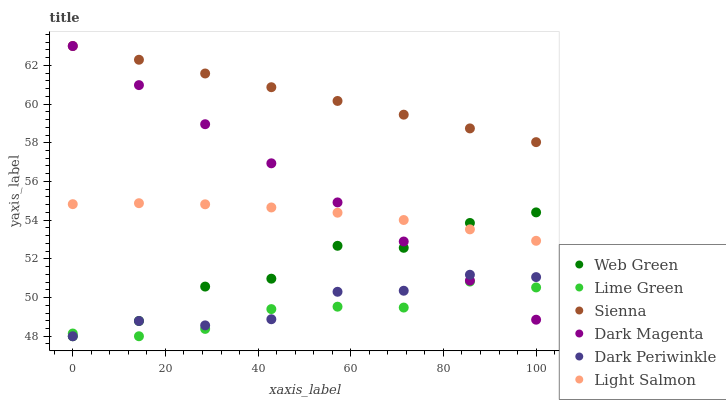Does Lime Green have the minimum area under the curve?
Answer yes or no. Yes. Does Sienna have the maximum area under the curve?
Answer yes or no. Yes. Does Dark Magenta have the minimum area under the curve?
Answer yes or no. No. Does Dark Magenta have the maximum area under the curve?
Answer yes or no. No. Is Sienna the smoothest?
Answer yes or no. Yes. Is Web Green the roughest?
Answer yes or no. Yes. Is Dark Magenta the smoothest?
Answer yes or no. No. Is Dark Magenta the roughest?
Answer yes or no. No. Does Web Green have the lowest value?
Answer yes or no. Yes. Does Dark Magenta have the lowest value?
Answer yes or no. No. Does Sienna have the highest value?
Answer yes or no. Yes. Does Web Green have the highest value?
Answer yes or no. No. Is Lime Green less than Light Salmon?
Answer yes or no. Yes. Is Sienna greater than Dark Periwinkle?
Answer yes or no. Yes. Does Sienna intersect Dark Magenta?
Answer yes or no. Yes. Is Sienna less than Dark Magenta?
Answer yes or no. No. Is Sienna greater than Dark Magenta?
Answer yes or no. No. Does Lime Green intersect Light Salmon?
Answer yes or no. No. 